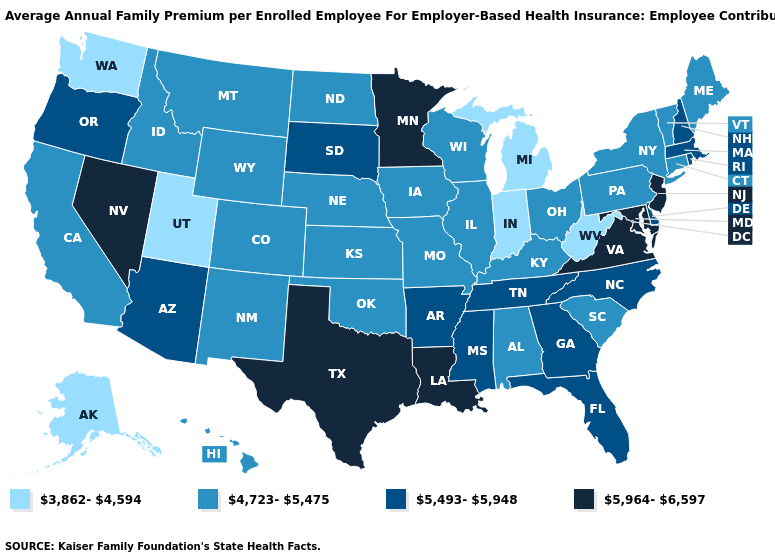Does the first symbol in the legend represent the smallest category?
Keep it brief. Yes. Which states hav the highest value in the Northeast?
Keep it brief. New Jersey. Name the states that have a value in the range 3,862-4,594?
Write a very short answer. Alaska, Indiana, Michigan, Utah, Washington, West Virginia. Does Illinois have the lowest value in the USA?
Give a very brief answer. No. Name the states that have a value in the range 5,493-5,948?
Be succinct. Arizona, Arkansas, Delaware, Florida, Georgia, Massachusetts, Mississippi, New Hampshire, North Carolina, Oregon, Rhode Island, South Dakota, Tennessee. What is the value of Louisiana?
Keep it brief. 5,964-6,597. Does Iowa have the highest value in the USA?
Give a very brief answer. No. Name the states that have a value in the range 4,723-5,475?
Answer briefly. Alabama, California, Colorado, Connecticut, Hawaii, Idaho, Illinois, Iowa, Kansas, Kentucky, Maine, Missouri, Montana, Nebraska, New Mexico, New York, North Dakota, Ohio, Oklahoma, Pennsylvania, South Carolina, Vermont, Wisconsin, Wyoming. How many symbols are there in the legend?
Concise answer only. 4. Name the states that have a value in the range 5,964-6,597?
Short answer required. Louisiana, Maryland, Minnesota, Nevada, New Jersey, Texas, Virginia. What is the value of Florida?
Give a very brief answer. 5,493-5,948. Name the states that have a value in the range 5,964-6,597?
Answer briefly. Louisiana, Maryland, Minnesota, Nevada, New Jersey, Texas, Virginia. Does Michigan have a lower value than Utah?
Be succinct. No. What is the highest value in the West ?
Concise answer only. 5,964-6,597. 